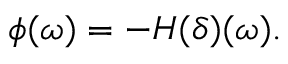Convert formula to latex. <formula><loc_0><loc_0><loc_500><loc_500>\phi ( \omega ) = - H ( \delta ) ( \omega ) .</formula> 